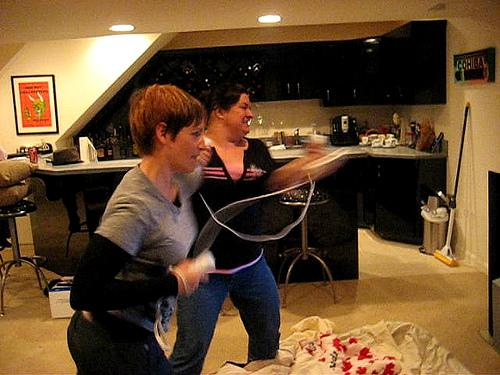Question: where was the picture taken?
Choices:
A. At the beach.
B. In a restaurant.
C. In a house.
D. In the park.
Answer with the letter. Answer: C Question: what gender are the people?
Choices:
A. Female.
B. Male.
C. Transgender.
D. Undecided.
Answer with the letter. Answer: A Question: what color is the floor?
Choices:
A. Beige.
B. White.
C. Brown.
D. Grey.
Answer with the letter. Answer: A Question: what color is the nearest woman's t-shirt?
Choices:
A. White.
B. Gray.
C. Green.
D. Red.
Answer with the letter. Answer: B Question: what kind of pants are the women wearing?
Choices:
A. Slacks.
B. Khakis.
C. Jeans.
D. Skin-tight.
Answer with the letter. Answer: C Question: what kind of game are the women playing?
Choices:
A. Nintendo.
B. Playstation.
C. Classic arcade machine.
D. Wii.
Answer with the letter. Answer: D 